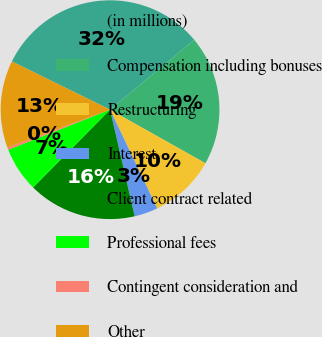Convert chart. <chart><loc_0><loc_0><loc_500><loc_500><pie_chart><fcel>(in millions)<fcel>Compensation including bonuses<fcel>Restructuring<fcel>Interest<fcel>Client contract related<fcel>Professional fees<fcel>Contingent consideration and<fcel>Other<nl><fcel>31.71%<fcel>19.17%<fcel>9.76%<fcel>3.48%<fcel>16.03%<fcel>6.62%<fcel>0.35%<fcel>12.89%<nl></chart> 